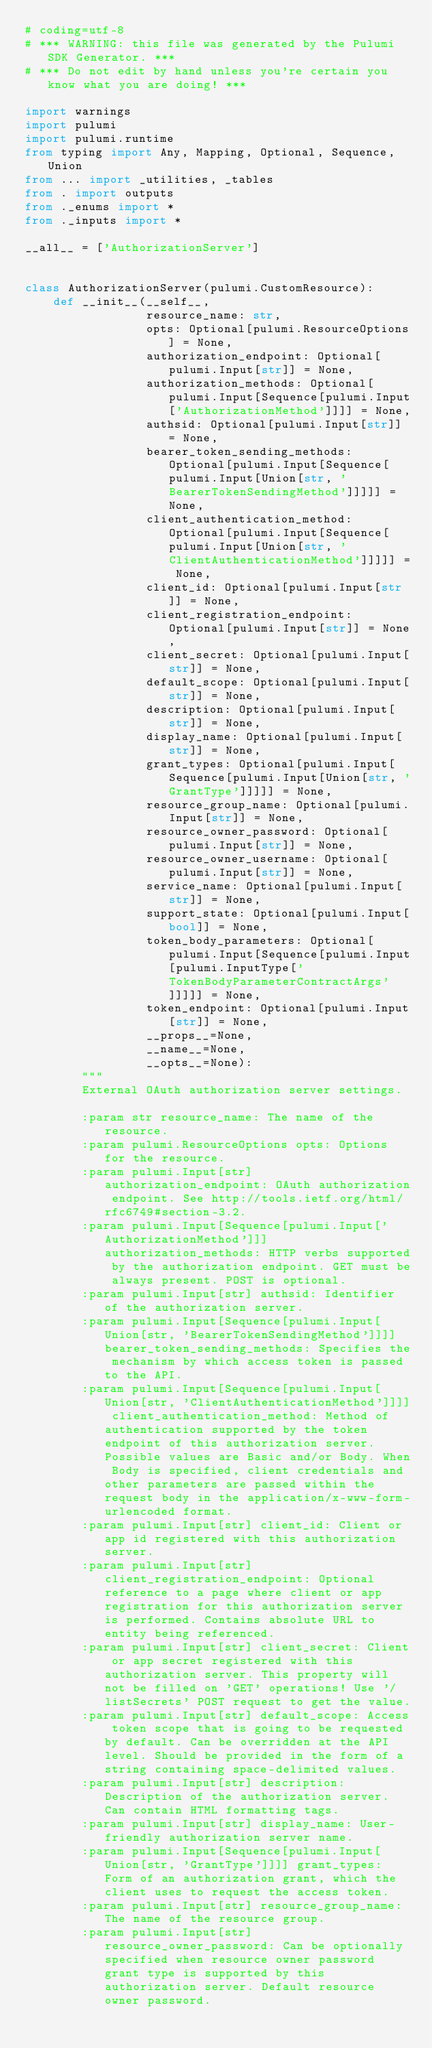Convert code to text. <code><loc_0><loc_0><loc_500><loc_500><_Python_># coding=utf-8
# *** WARNING: this file was generated by the Pulumi SDK Generator. ***
# *** Do not edit by hand unless you're certain you know what you are doing! ***

import warnings
import pulumi
import pulumi.runtime
from typing import Any, Mapping, Optional, Sequence, Union
from ... import _utilities, _tables
from . import outputs
from ._enums import *
from ._inputs import *

__all__ = ['AuthorizationServer']


class AuthorizationServer(pulumi.CustomResource):
    def __init__(__self__,
                 resource_name: str,
                 opts: Optional[pulumi.ResourceOptions] = None,
                 authorization_endpoint: Optional[pulumi.Input[str]] = None,
                 authorization_methods: Optional[pulumi.Input[Sequence[pulumi.Input['AuthorizationMethod']]]] = None,
                 authsid: Optional[pulumi.Input[str]] = None,
                 bearer_token_sending_methods: Optional[pulumi.Input[Sequence[pulumi.Input[Union[str, 'BearerTokenSendingMethod']]]]] = None,
                 client_authentication_method: Optional[pulumi.Input[Sequence[pulumi.Input[Union[str, 'ClientAuthenticationMethod']]]]] = None,
                 client_id: Optional[pulumi.Input[str]] = None,
                 client_registration_endpoint: Optional[pulumi.Input[str]] = None,
                 client_secret: Optional[pulumi.Input[str]] = None,
                 default_scope: Optional[pulumi.Input[str]] = None,
                 description: Optional[pulumi.Input[str]] = None,
                 display_name: Optional[pulumi.Input[str]] = None,
                 grant_types: Optional[pulumi.Input[Sequence[pulumi.Input[Union[str, 'GrantType']]]]] = None,
                 resource_group_name: Optional[pulumi.Input[str]] = None,
                 resource_owner_password: Optional[pulumi.Input[str]] = None,
                 resource_owner_username: Optional[pulumi.Input[str]] = None,
                 service_name: Optional[pulumi.Input[str]] = None,
                 support_state: Optional[pulumi.Input[bool]] = None,
                 token_body_parameters: Optional[pulumi.Input[Sequence[pulumi.Input[pulumi.InputType['TokenBodyParameterContractArgs']]]]] = None,
                 token_endpoint: Optional[pulumi.Input[str]] = None,
                 __props__=None,
                 __name__=None,
                 __opts__=None):
        """
        External OAuth authorization server settings.

        :param str resource_name: The name of the resource.
        :param pulumi.ResourceOptions opts: Options for the resource.
        :param pulumi.Input[str] authorization_endpoint: OAuth authorization endpoint. See http://tools.ietf.org/html/rfc6749#section-3.2.
        :param pulumi.Input[Sequence[pulumi.Input['AuthorizationMethod']]] authorization_methods: HTTP verbs supported by the authorization endpoint. GET must be always present. POST is optional.
        :param pulumi.Input[str] authsid: Identifier of the authorization server.
        :param pulumi.Input[Sequence[pulumi.Input[Union[str, 'BearerTokenSendingMethod']]]] bearer_token_sending_methods: Specifies the mechanism by which access token is passed to the API. 
        :param pulumi.Input[Sequence[pulumi.Input[Union[str, 'ClientAuthenticationMethod']]]] client_authentication_method: Method of authentication supported by the token endpoint of this authorization server. Possible values are Basic and/or Body. When Body is specified, client credentials and other parameters are passed within the request body in the application/x-www-form-urlencoded format.
        :param pulumi.Input[str] client_id: Client or app id registered with this authorization server.
        :param pulumi.Input[str] client_registration_endpoint: Optional reference to a page where client or app registration for this authorization server is performed. Contains absolute URL to entity being referenced.
        :param pulumi.Input[str] client_secret: Client or app secret registered with this authorization server. This property will not be filled on 'GET' operations! Use '/listSecrets' POST request to get the value.
        :param pulumi.Input[str] default_scope: Access token scope that is going to be requested by default. Can be overridden at the API level. Should be provided in the form of a string containing space-delimited values.
        :param pulumi.Input[str] description: Description of the authorization server. Can contain HTML formatting tags.
        :param pulumi.Input[str] display_name: User-friendly authorization server name.
        :param pulumi.Input[Sequence[pulumi.Input[Union[str, 'GrantType']]]] grant_types: Form of an authorization grant, which the client uses to request the access token.
        :param pulumi.Input[str] resource_group_name: The name of the resource group.
        :param pulumi.Input[str] resource_owner_password: Can be optionally specified when resource owner password grant type is supported by this authorization server. Default resource owner password.</code> 